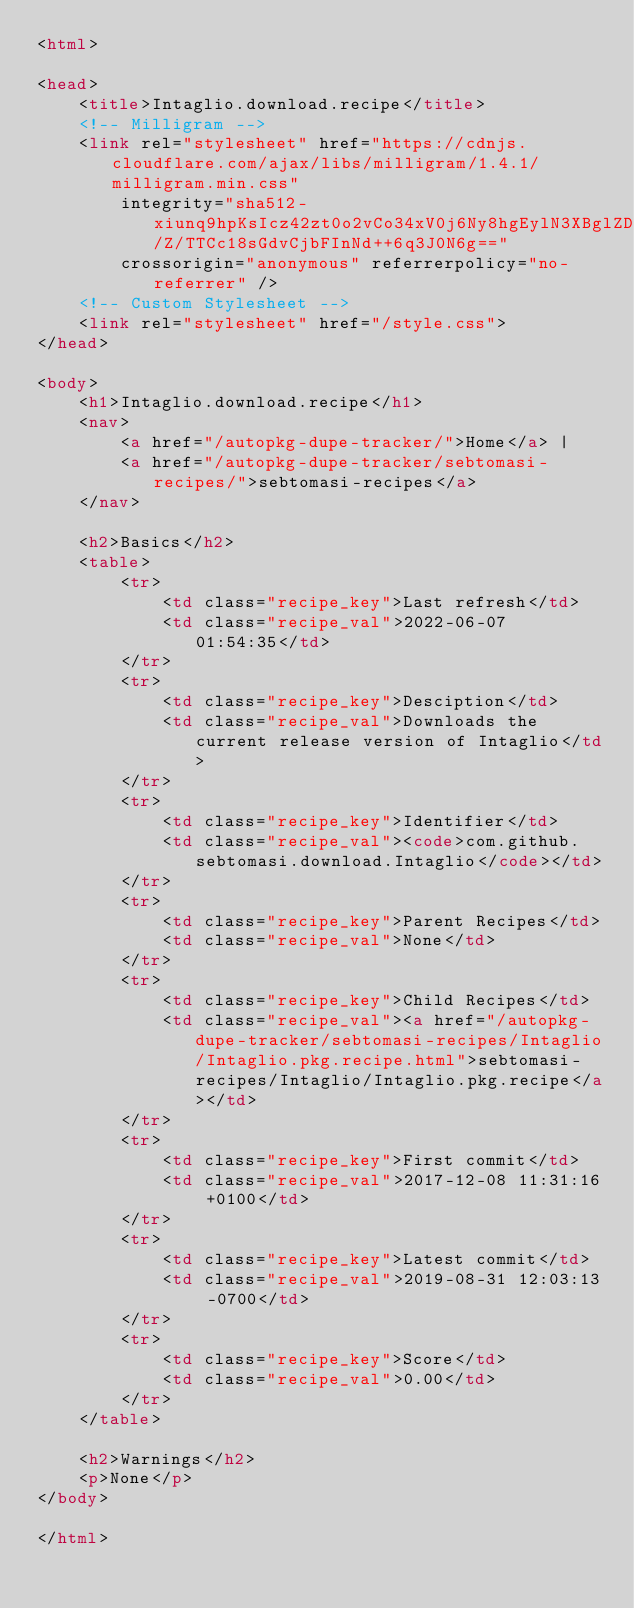Convert code to text. <code><loc_0><loc_0><loc_500><loc_500><_HTML_><html>

<head>
    <title>Intaglio.download.recipe</title>
    <!-- Milligram -->
    <link rel="stylesheet" href="https://cdnjs.cloudflare.com/ajax/libs/milligram/1.4.1/milligram.min.css"
        integrity="sha512-xiunq9hpKsIcz42zt0o2vCo34xV0j6Ny8hgEylN3XBglZDtTZ2nwnqF/Z/TTCc18sGdvCjbFInNd++6q3J0N6g=="
        crossorigin="anonymous" referrerpolicy="no-referrer" />
    <!-- Custom Stylesheet -->
    <link rel="stylesheet" href="/style.css">
</head>

<body>
    <h1>Intaglio.download.recipe</h1>
    <nav>
        <a href="/autopkg-dupe-tracker/">Home</a> |
        <a href="/autopkg-dupe-tracker/sebtomasi-recipes/">sebtomasi-recipes</a>
    </nav>

    <h2>Basics</h2>
    <table>
        <tr>
            <td class="recipe_key">Last refresh</td>
            <td class="recipe_val">2022-06-07 01:54:35</td>
        </tr>
        <tr>
            <td class="recipe_key">Desciption</td>
            <td class="recipe_val">Downloads the current release version of Intaglio</td>
        </tr>
        <tr>
            <td class="recipe_key">Identifier</td>
            <td class="recipe_val"><code>com.github.sebtomasi.download.Intaglio</code></td>
        </tr>
        <tr>
            <td class="recipe_key">Parent Recipes</td>
            <td class="recipe_val">None</td>
        </tr>
        <tr>
            <td class="recipe_key">Child Recipes</td>
            <td class="recipe_val"><a href="/autopkg-dupe-tracker/sebtomasi-recipes/Intaglio/Intaglio.pkg.recipe.html">sebtomasi-recipes/Intaglio/Intaglio.pkg.recipe</a></td>
        </tr>
        <tr>
            <td class="recipe_key">First commit</td>
            <td class="recipe_val">2017-12-08 11:31:16 +0100</td>
        </tr>
        <tr>
            <td class="recipe_key">Latest commit</td>
            <td class="recipe_val">2019-08-31 12:03:13 -0700</td>
        </tr>
        <tr>
            <td class="recipe_key">Score</td>
            <td class="recipe_val">0.00</td>
        </tr>
    </table>

    <h2>Warnings</h2>
    <p>None</p>
</body>

</html>
</code> 